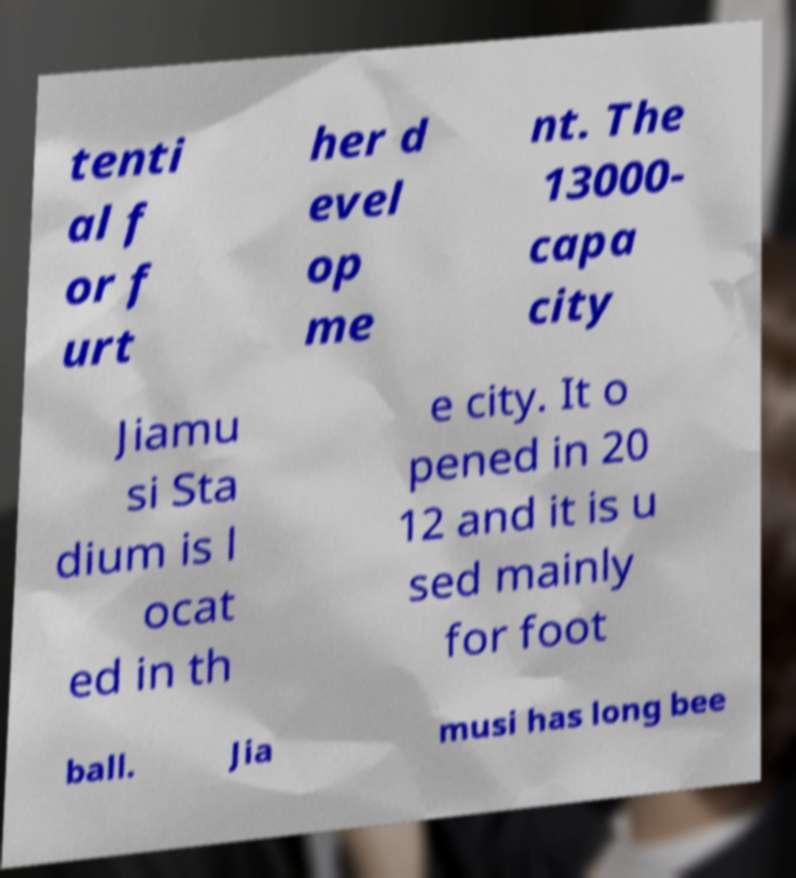There's text embedded in this image that I need extracted. Can you transcribe it verbatim? tenti al f or f urt her d evel op me nt. The 13000- capa city Jiamu si Sta dium is l ocat ed in th e city. It o pened in 20 12 and it is u sed mainly for foot ball. Jia musi has long bee 